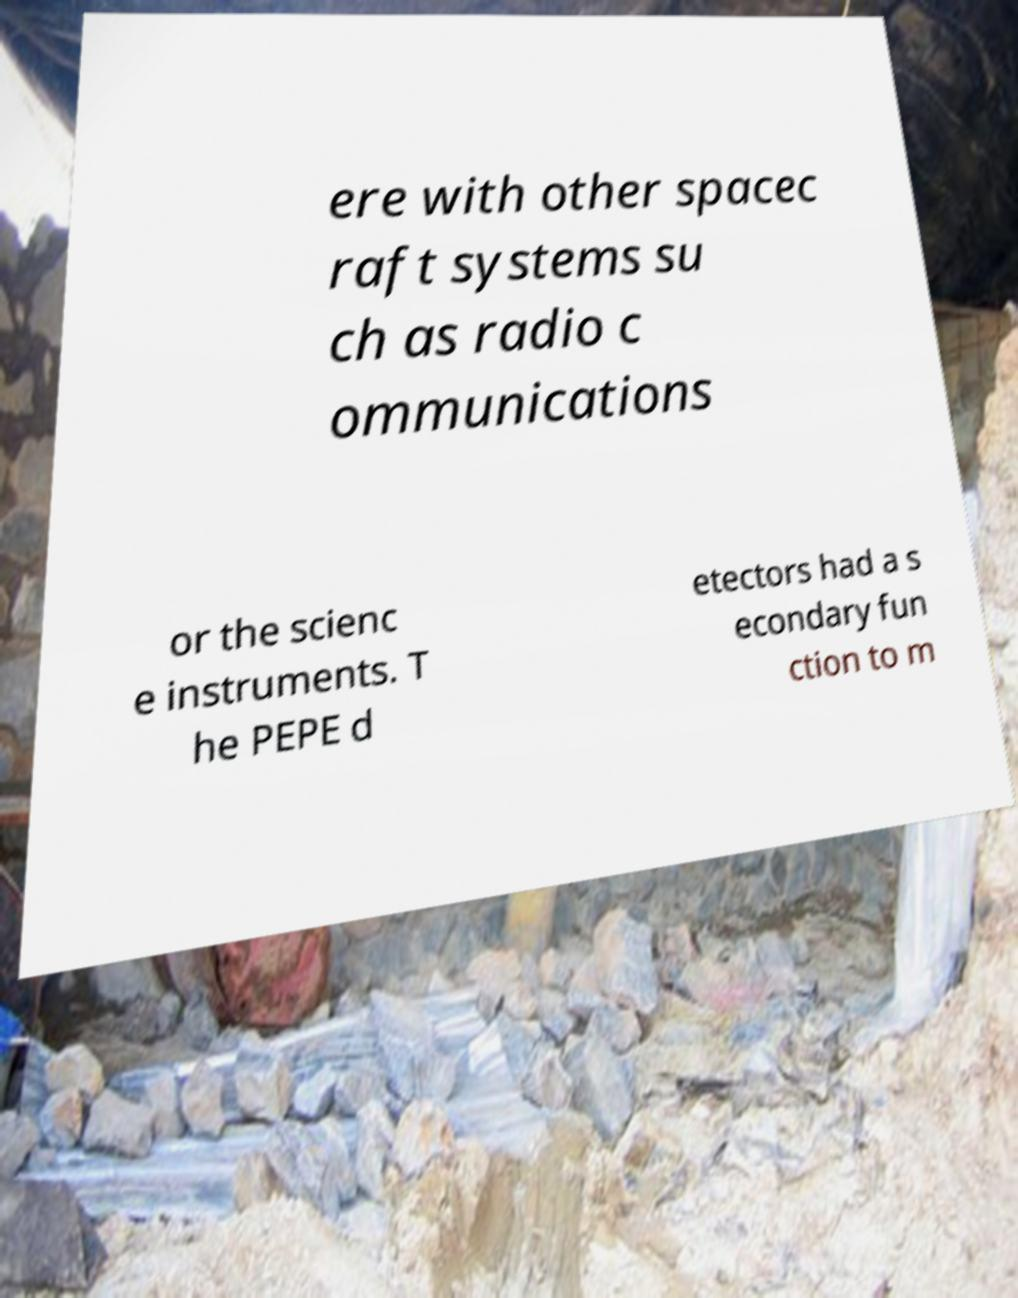What messages or text are displayed in this image? I need them in a readable, typed format. ere with other spacec raft systems su ch as radio c ommunications or the scienc e instruments. T he PEPE d etectors had a s econdary fun ction to m 